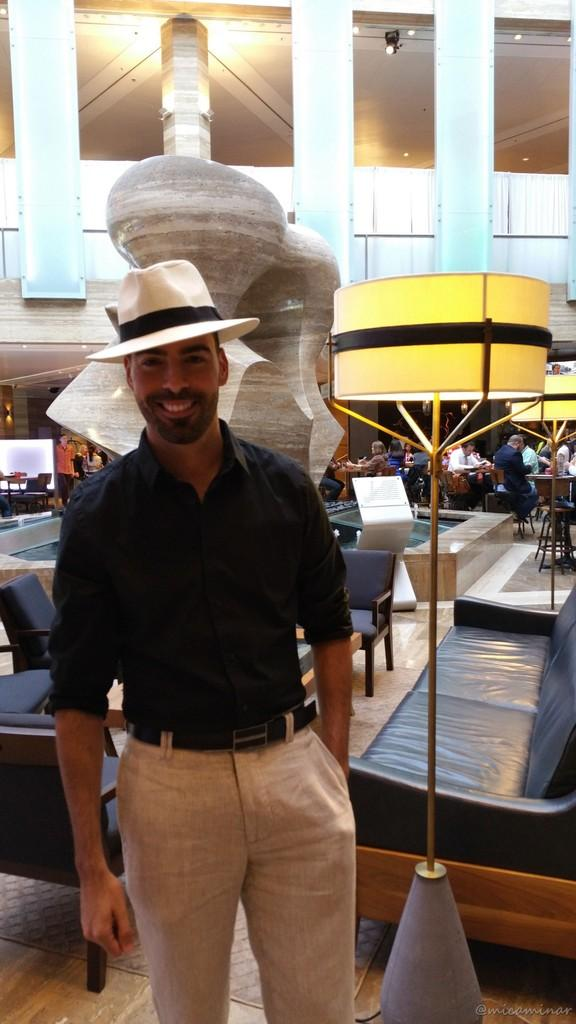What is the person in the image doing? The person in the image is standing and smiling. What can be seen in the background of the image? There is a sofa in the background of the image. What object is providing light in the image? There is a lamp in the image. What type of lighting is visible in the image? There are lights visible in the image. How are the other people in the image positioned? There is a group of people sitting on chairs in the image. What type of mark can be seen on the frog in the image? There is no frog present in the image, so it is not possible to determine if there is a mark on it. 